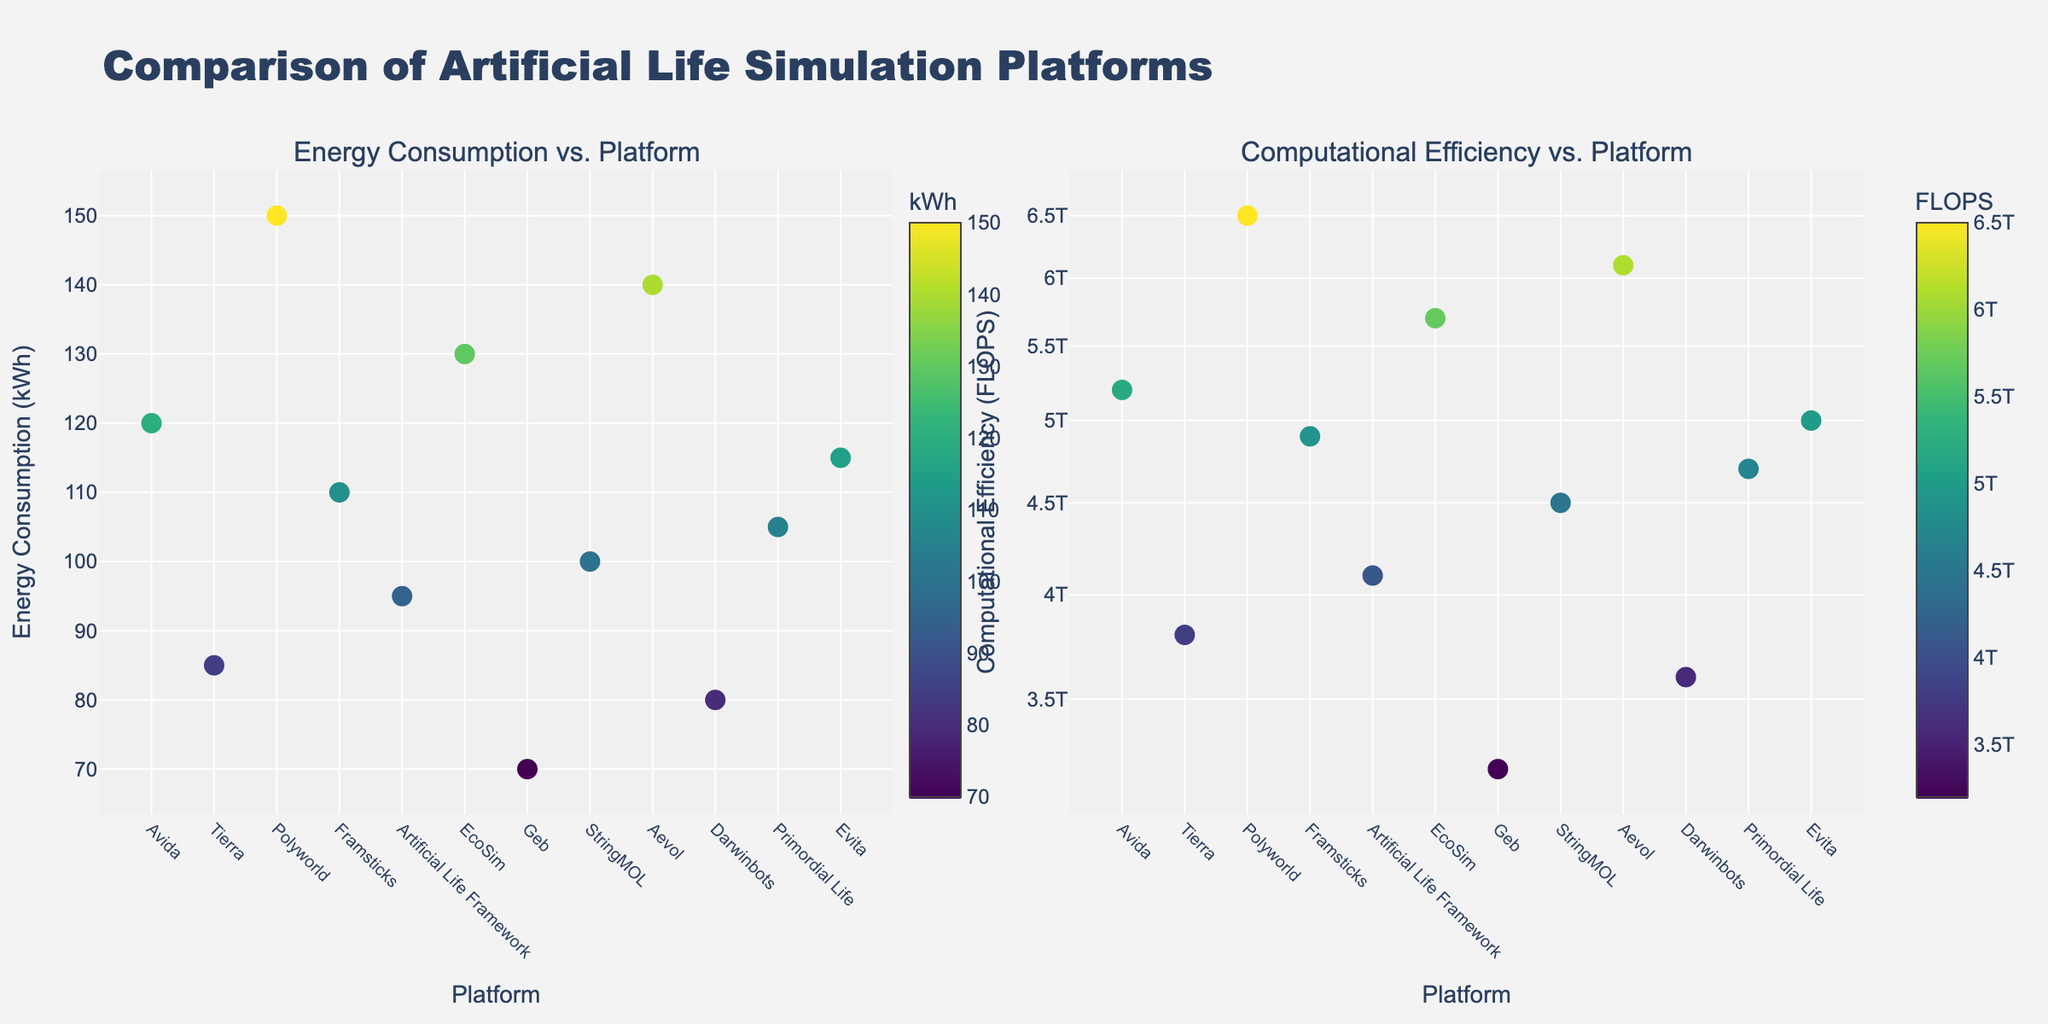Which country has the highest number of visitors? Look at the bar chart on the right and identify the tallest bar. The tallest bar corresponds to Turkey, which has 51.2 million visitors.
Answer: Turkey What is the average length of stay in Australia? Refer to the scatter plot on the left and locate the data point labeled "Australia." The average stay beside Australia is shown as 21 days.
Answer: 21 days Which country has the shortest average stay among the listed countries? Check the scatter plot for the smallest value on the x-axis (Average Stay in days). The smallest value is 6 days, which corresponds to Iceland and UAE.
Answer: Iceland and UAE How many countries have an average stay of 10 days? On the scatter plot, count the number of points that have an x-value of 10. The countries with an average stay of 10 days are Vietnam, Turkey, Peru, and Tanzania. Therefore, there are 4 such countries.
Answer: 4 Which country has more visitors: Thailand or Japan? Refer to the y-axis values of Thailand and Japan on the scatter plot or bar chart. Thailand has 39.8 million visitors, whereas Japan has 32.2 million.
Answer: Thailand What is the combined number of visitors for Greece and Portugal? Look at the y-values for Greece and Portugal on the bar chart and add them. Greece has 34.0 million visitors, and Portugal has 27.0 million visitors. The sum is 34.0 + 27.0 = 61.0 million.
Answer: 61.0 million Which country has the longest average stay? Check the scatter plot for the highest x-axis value (Average Stay in days). The highest value is 21 days, which corresponds to Australia.
Answer: Australia Do any countries have the same number of visitors? If yes, which countries? Examine the y-axis values on both the scatter plot and bar chart to see if any countries share the same visitor numbers. None of the countries have the same number of visitors.
Answer: No What is the difference in the number of visitors between Vietnam and South Korea? Refer to the y-values for Vietnam and South Korea. Vietnam has 18.0 million visitors, and South Korea has 17.5 million visitors. The difference is 18.0 - 17.5 = 0.5 million.
Answer: 0.5 million Which country has the highest visitors per day of average stay? To find visitors per day, divide the number of visitors by the average stay for each country and identify the highest ratio. Thailand has 39.8 million visitors and an average stay of 9 days, resulting in 39.8 / 9 ≈ 4.42. No other country has a higher value.
Answer: Thailand 